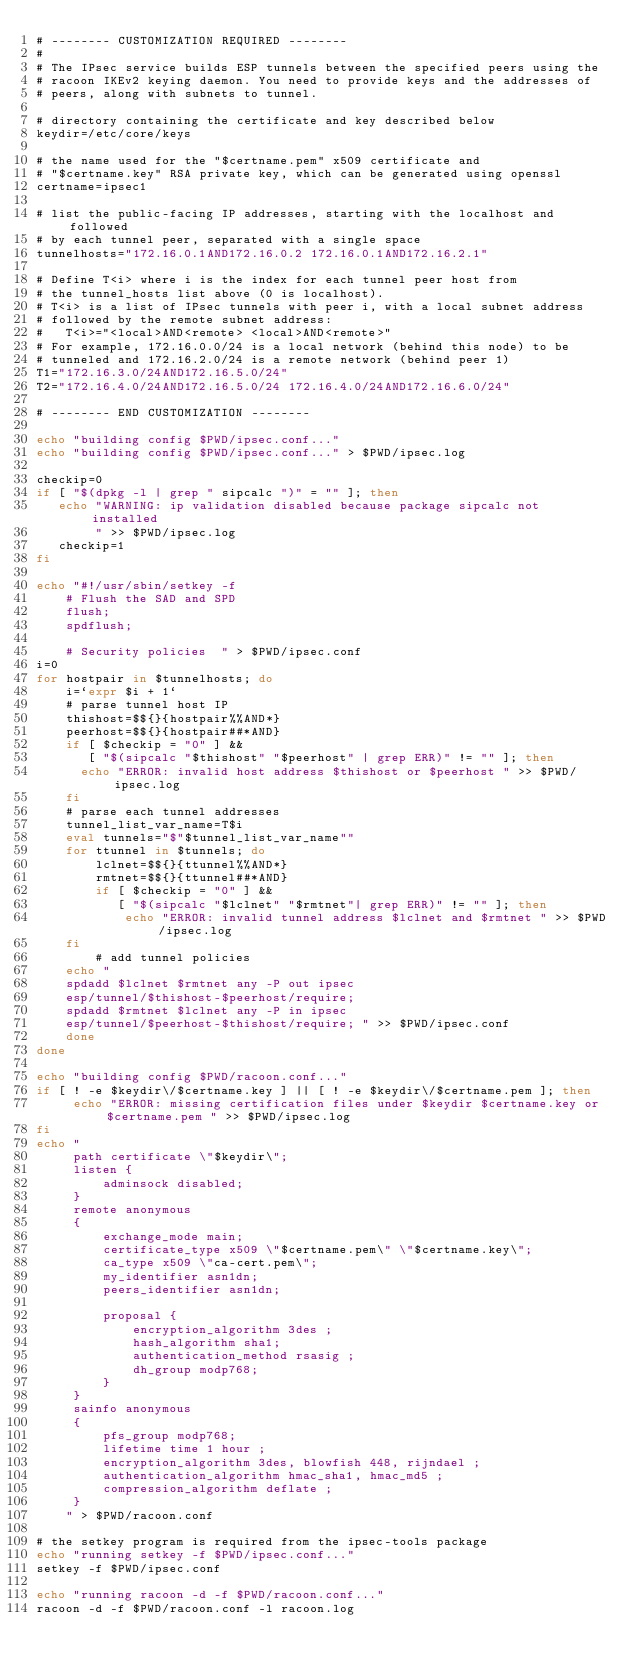<code> <loc_0><loc_0><loc_500><loc_500><_Bash_># -------- CUSTOMIZATION REQUIRED --------
#
# The IPsec service builds ESP tunnels between the specified peers using the
# racoon IKEv2 keying daemon. You need to provide keys and the addresses of
# peers, along with subnets to tunnel.

# directory containing the certificate and key described below
keydir=/etc/core/keys

# the name used for the "$certname.pem" x509 certificate and
# "$certname.key" RSA private key, which can be generated using openssl
certname=ipsec1

# list the public-facing IP addresses, starting with the localhost and followed
# by each tunnel peer, separated with a single space
tunnelhosts="172.16.0.1AND172.16.0.2 172.16.0.1AND172.16.2.1"

# Define T<i> where i is the index for each tunnel peer host from
# the tunnel_hosts list above (0 is localhost).
# T<i> is a list of IPsec tunnels with peer i, with a local subnet address
# followed by the remote subnet address:
#   T<i>="<local>AND<remote> <local>AND<remote>"
# For example, 172.16.0.0/24 is a local network (behind this node) to be
# tunneled and 172.16.2.0/24 is a remote network (behind peer 1)
T1="172.16.3.0/24AND172.16.5.0/24"
T2="172.16.4.0/24AND172.16.5.0/24 172.16.4.0/24AND172.16.6.0/24"

# -------- END CUSTOMIZATION --------

echo "building config $PWD/ipsec.conf..."
echo "building config $PWD/ipsec.conf..." > $PWD/ipsec.log

checkip=0
if [ "$(dpkg -l | grep " sipcalc ")" = "" ]; then
   echo "WARNING: ip validation disabled because package sipcalc not installed
        " >> $PWD/ipsec.log
   checkip=1
fi

echo "#!/usr/sbin/setkey -f
    # Flush the SAD and SPD
    flush;
    spdflush;

    # Security policies  " > $PWD/ipsec.conf
i=0
for hostpair in $tunnelhosts; do
    i=`expr $i + 1`
    # parse tunnel host IP
    thishost=$${}{hostpair%%AND*}
    peerhost=$${}{hostpair##*AND}
    if [ $checkip = "0" ] &&
       [ "$(sipcalc "$thishost" "$peerhost" | grep ERR)" != "" ]; then
	  echo "ERROR: invalid host address $thishost or $peerhost " >> $PWD/ipsec.log
    fi
    # parse each tunnel addresses
    tunnel_list_var_name=T$i
    eval tunnels="$"$tunnel_list_var_name""
    for ttunnel in $tunnels; do
        lclnet=$${}{ttunnel%%AND*}
        rmtnet=$${}{ttunnel##*AND}
    	if [ $checkip = "0" ] &&
           [ "$(sipcalc "$lclnet" "$rmtnet"| grep ERR)" != "" ]; then
    	    echo "ERROR: invalid tunnel address $lclnet and $rmtnet " >> $PWD/ipsec.log
	fi
    	# add tunnel policies
	echo "
    spdadd $lclnet $rmtnet any -P out ipsec
	esp/tunnel/$thishost-$peerhost/require;
    spdadd $rmtnet $lclnet any -P in ipsec
	esp/tunnel/$peerhost-$thishost/require; " >> $PWD/ipsec.conf
    done
done

echo "building config $PWD/racoon.conf..."
if [ ! -e $keydir\/$certname.key ] || [ ! -e $keydir\/$certname.pem ]; then
     echo "ERROR: missing certification files under $keydir $certname.key or $certname.pem " >> $PWD/ipsec.log
fi
echo "
	 path certificate \"$keydir\";
	 listen {
		 adminsock disabled;
	 }
	 remote anonymous
	 {
		 exchange_mode main;
 		 certificate_type x509 \"$certname.pem\" \"$certname.key\";
		 ca_type x509 \"ca-cert.pem\";
		 my_identifier asn1dn;
		 peers_identifier asn1dn;

		 proposal {
			 encryption_algorithm 3des ;
			 hash_algorithm sha1;
			 authentication_method rsasig ;
			 dh_group modp768;
		 }
	 }
	 sainfo anonymous
	 {
		 pfs_group modp768;
		 lifetime time 1 hour ;
		 encryption_algorithm 3des, blowfish 448, rijndael ;
		 authentication_algorithm hmac_sha1, hmac_md5 ;
		 compression_algorithm deflate ;
	 }
	" > $PWD/racoon.conf

# the setkey program is required from the ipsec-tools package
echo "running setkey -f $PWD/ipsec.conf..."
setkey -f $PWD/ipsec.conf

echo "running racoon -d -f $PWD/racoon.conf..."
racoon -d -f $PWD/racoon.conf -l racoon.log
</code> 